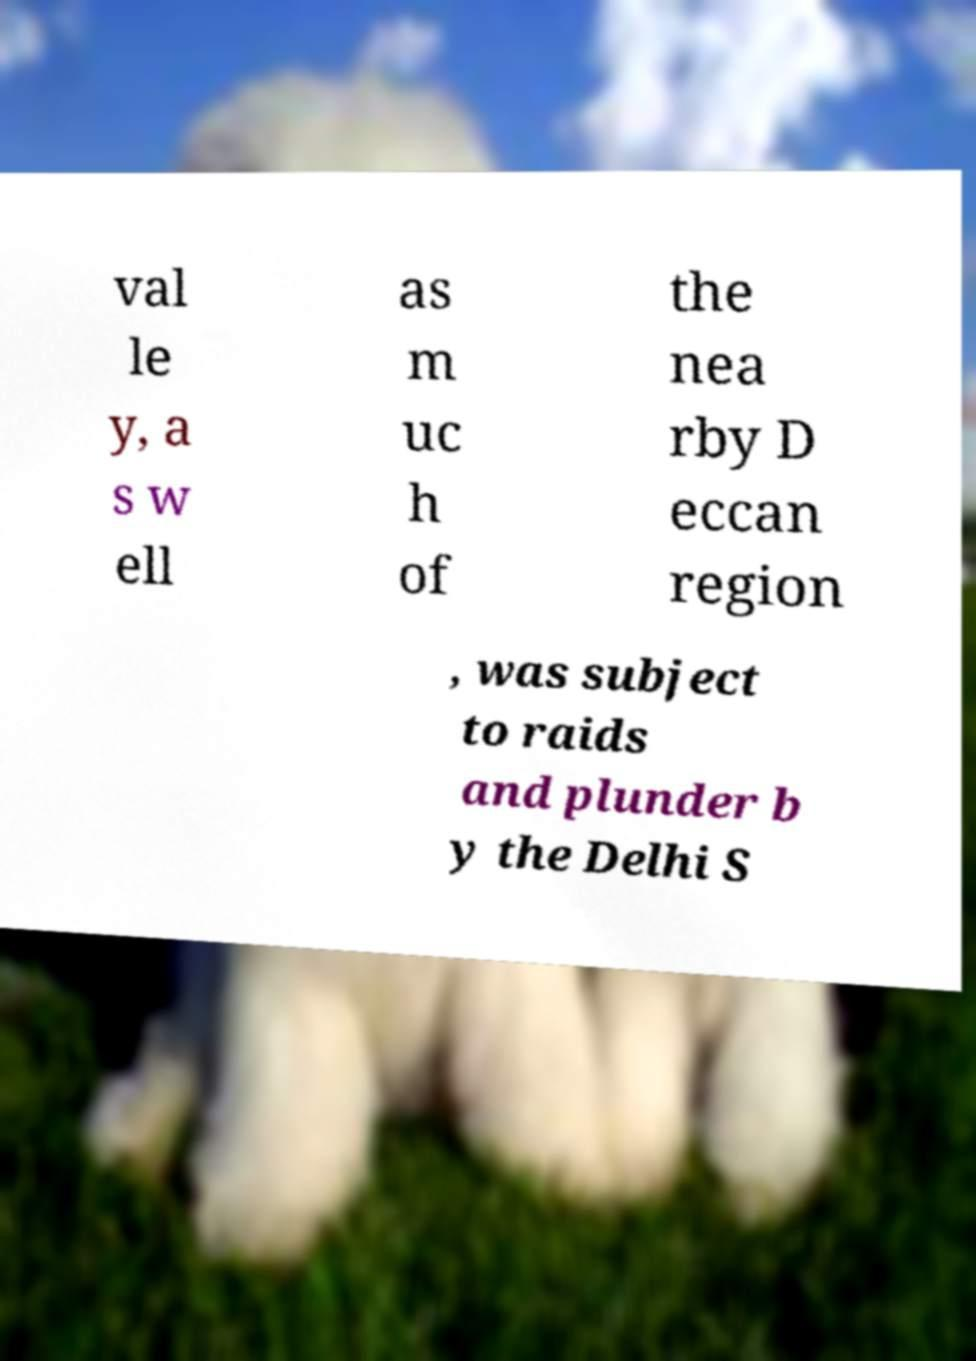Could you assist in decoding the text presented in this image and type it out clearly? val le y, a s w ell as m uc h of the nea rby D eccan region , was subject to raids and plunder b y the Delhi S 